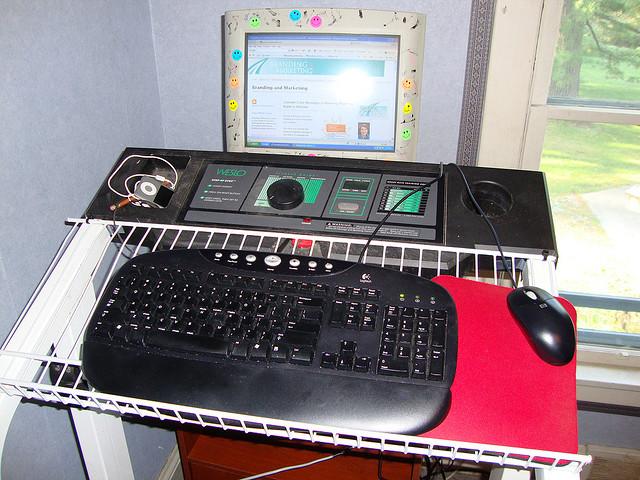What color is the mouse?
Short answer required. Black. Is there anyone in the pic?
Be succinct. No. How many screens are in the image?
Be succinct. 1. 